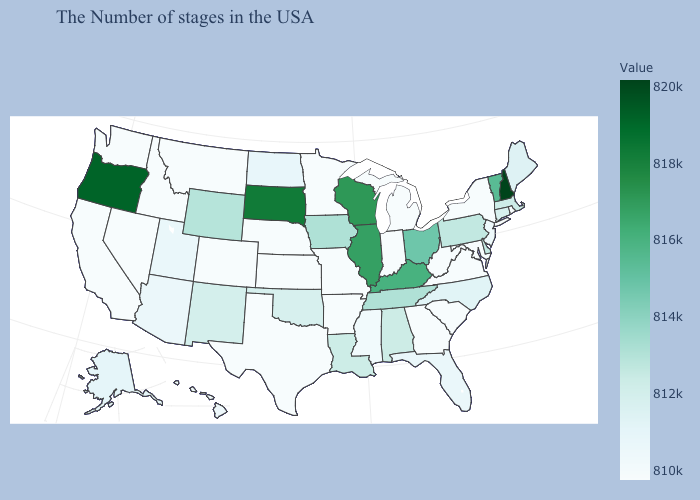Is the legend a continuous bar?
Write a very short answer. Yes. Does the map have missing data?
Short answer required. No. Among the states that border Oklahoma , which have the lowest value?
Short answer required. Missouri, Arkansas, Kansas, Texas, Colorado. Does the map have missing data?
Give a very brief answer. No. Among the states that border Wyoming , which have the highest value?
Short answer required. South Dakota. Which states hav the highest value in the South?
Short answer required. Kentucky. 